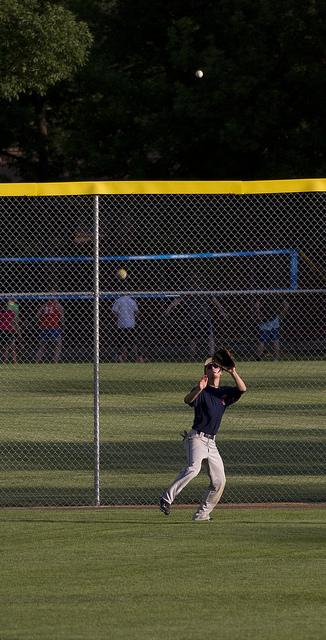What position is this player playing? Please explain your reasoning. outfielder. The outfielder is always playing on the side of the field. 